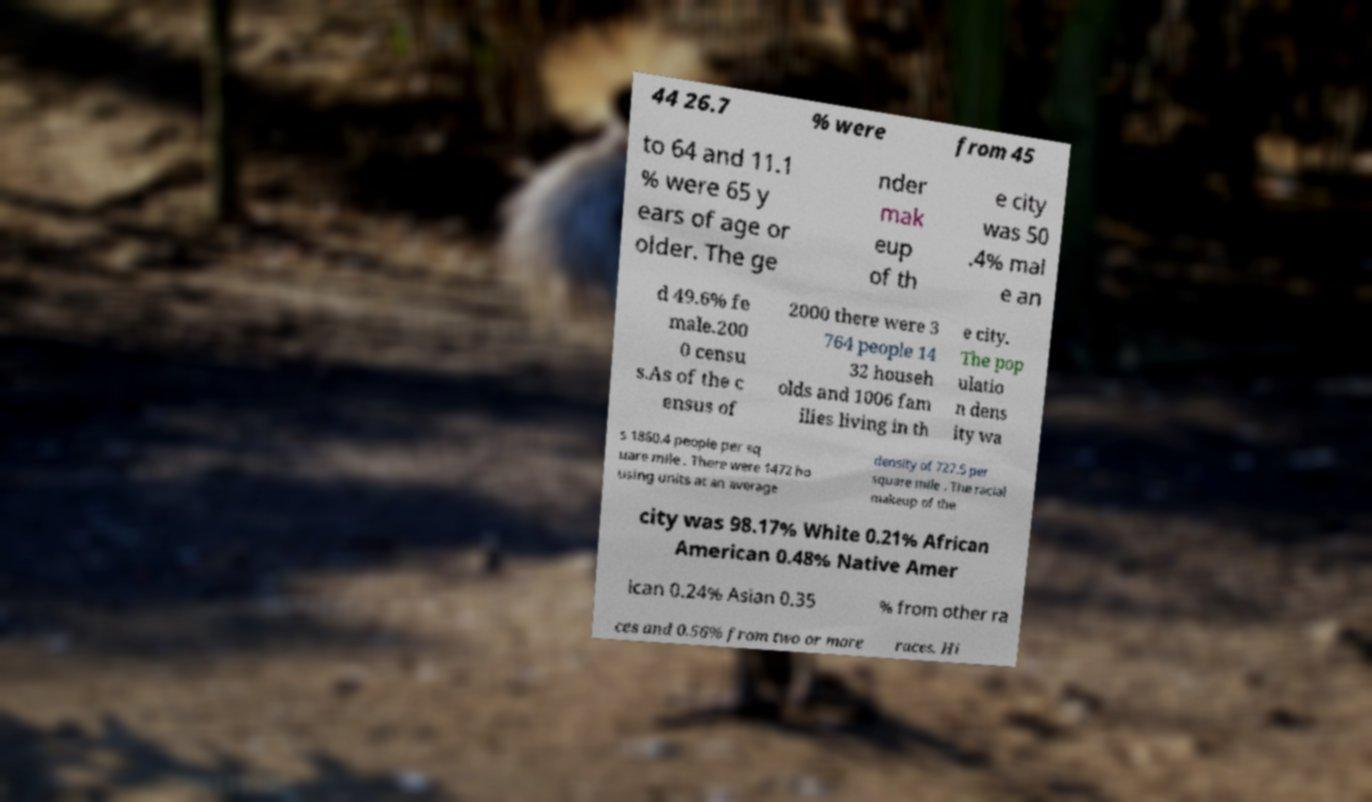Can you accurately transcribe the text from the provided image for me? 44 26.7 % were from 45 to 64 and 11.1 % were 65 y ears of age or older. The ge nder mak eup of th e city was 50 .4% mal e an d 49.6% fe male.200 0 censu s.As of the c ensus of 2000 there were 3 764 people 14 32 househ olds and 1006 fam ilies living in th e city. The pop ulatio n dens ity wa s 1860.4 people per sq uare mile . There were 1472 ho using units at an average density of 727.5 per square mile . The racial makeup of the city was 98.17% White 0.21% African American 0.48% Native Amer ican 0.24% Asian 0.35 % from other ra ces and 0.56% from two or more races. Hi 